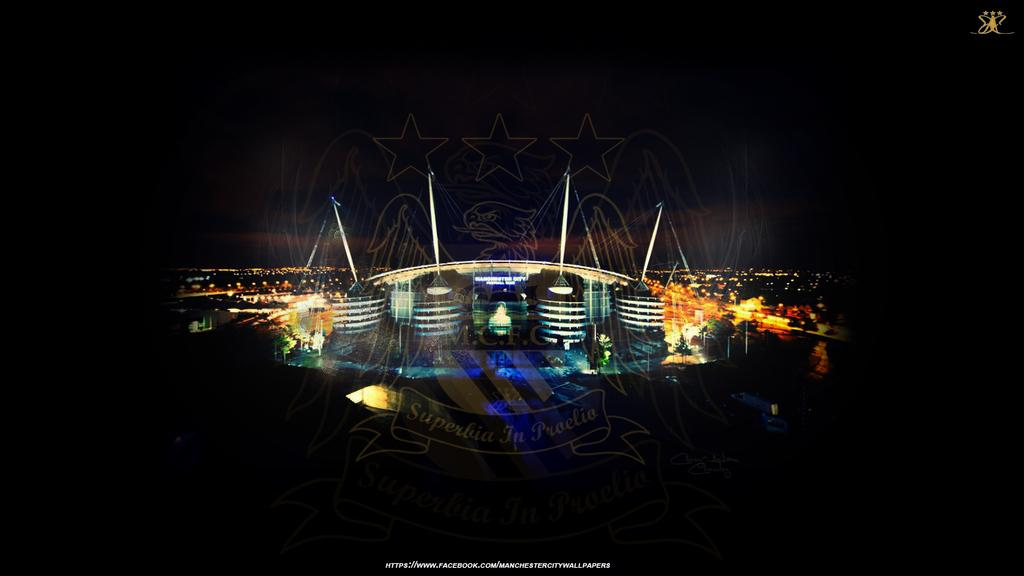What is the main subject of the image? There is a poster in the image. What type of images are on the poster? The poster contains images of buildings. Are there any additional features on the poster? Yes, the poster has watermarks. What can be observed about the corners of the image? The corners of the image are dark. What type of blade is being used to stir the soup in the image? There is no soup or blade present in the image; it features a poster with images of buildings and watermarks. What is the opinion of the person in the image regarding the buildings? The image does not depict a person or convey any opinions about the buildings; it is a poster with images of buildings and watermarks. 